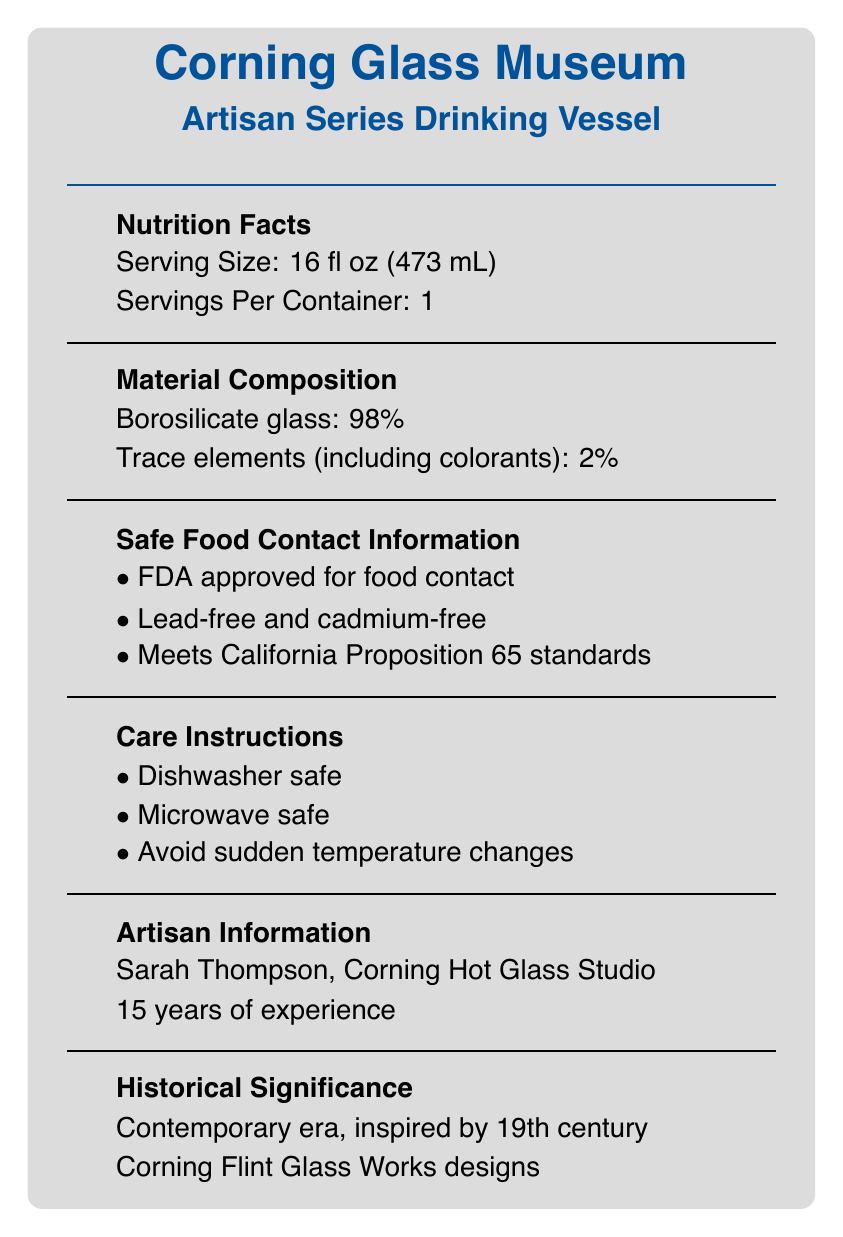what is the serving size? The serving size is stated directly in the document under "Serving Size: 16 fl oz (473 mL)".
Answer: 16 fl oz (473 mL) how many servings are in one container? The number of servings per container is mentioned as "Servings Per Container: 1".
Answer: 1 what are the safety standards for food contact mentioned? The document lists three safety standards for food contact in the "Safe Food Contact Information" section.
Answer: FDA approved for food contact, Lead-free and cadmium-free, Meets California Proposition 65 standards who is the artisan behind the drinking vessel? The artisan information is listed as "Sarah Thompson, Corning Hot Glass Studio".
Answer: Sarah Thompson how much borosilicate glass is in the composition? The material composition section states that borosilicate glass constitutes 98% of the composition.
Answer: 98% what era and inspiration are referenced in the historical significance section? The historical significance section mentions that the vessel belongs to the Contemporary era and is inspired by 19th-century Corning Flint Glass Works designs.
Answer: Contemporary era, inspired by 19th century Corning Flint Glass Works designs which care instruction is NOT mentioned in the document? A. Hand wash only B. Dishwasher safe C. Microwave safe D. Avoid sudden temperature changes The document mentions "Dishwasher safe", "Microwave safe", and "Avoid sudden temperature changes" but not "Hand wash only".
Answer: A. Hand wash only how many years of experience does the artisan have? A. 10 years B. 15 years C. 20 years D. 25 years The document notes that Sarah Thompson has 15 years of experience under the "Artisan Information" section.
Answer: B. 15 years is the vessel safe to use in a microwave oven? The care instructions specifically mention that the vessel is "Microwave safe".
Answer: Yes what is the main idea of this document? The document comprehensively describes various aspects of the specialty glass-blown drinking vessel, including its composition, safety, care instructions, and background.
Answer: The document is a detailed overview of the "Corning Glass Museum Artisan Series Drinking Vessel," highlighting its materials, safety standards, care instructions, artisan information, historical significance, and other features. are there any details about the manufacturing cost in the document? The document does not provide any information about the manufacturing cost.
Answer: Not enough information what type of glass is used primarily in the vessel's composition? The material composition section mentions that the vessel is made up of 98% borosilicate glass.
Answer: Borosilicate glass is the drinking vessel recommended to be subjected to sudden temperature changes? The care instructions advise to "Avoid sudden temperature changes."
Answer: No which certifications does the document mention? The certifications mentioned in the document are "Corning Museum of Glass Seal of Authenticity" and "New York State Artisan Crafted".
Answer: Corning Museum of Glass Seal of Authenticity, New York State Artisan Crafted 